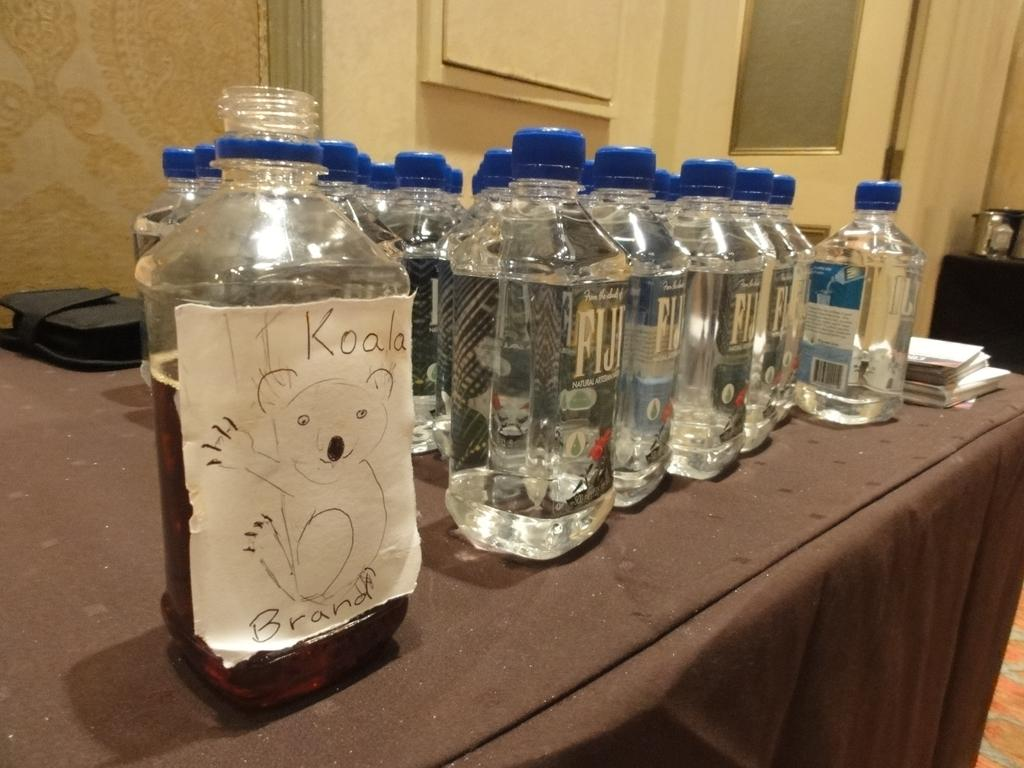<image>
Render a clear and concise summary of the photo. A number of watter bottles the nearest of which has a handwritten lable saying Koala Brand. 